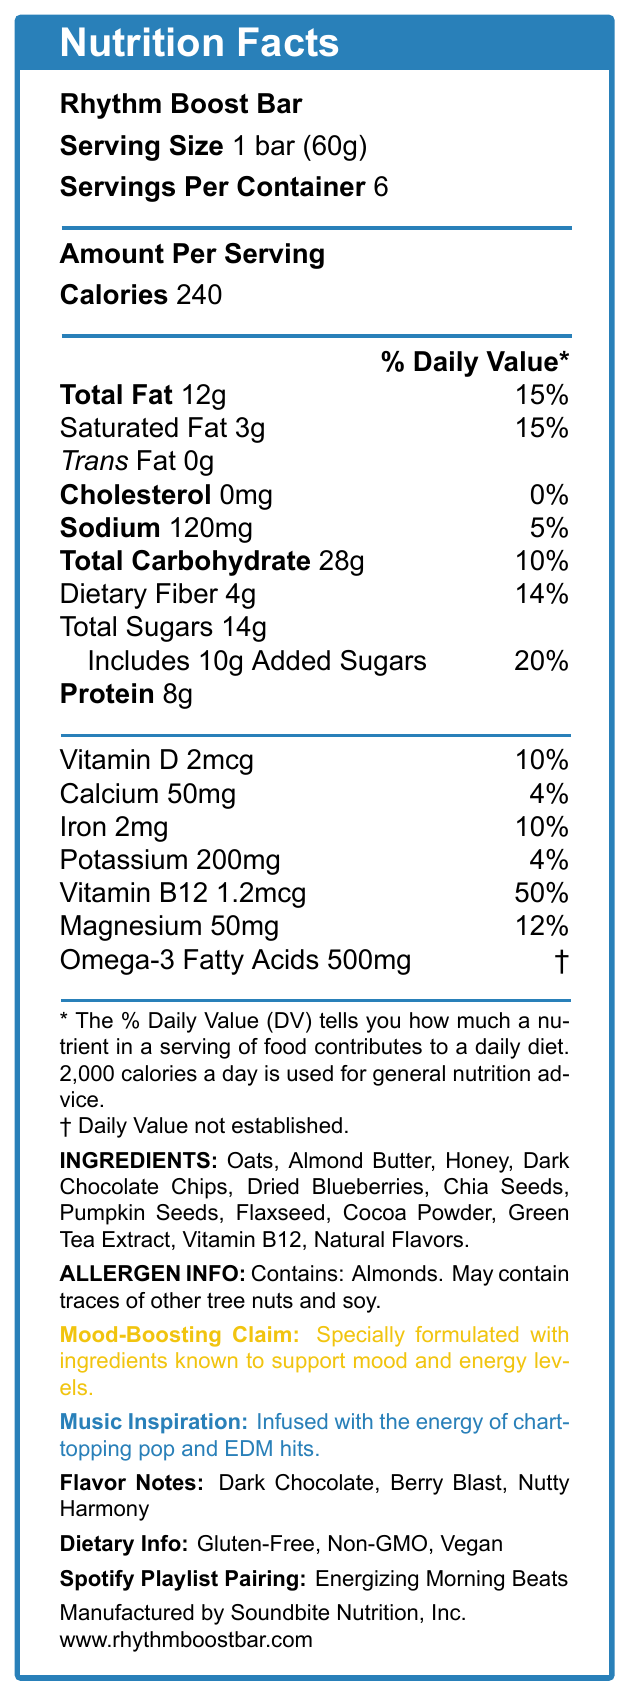what is the serving size of the Rhythm Boost Bar? The serving size is explicitly mentioned as "1 bar (60g)" in the document.
Answer: 1 bar (60g) how many servings are there per container? The document states "Servings Per Container: 6".
Answer: 6 how many calories are there per serving? "Calories" are listed as "240" under "Amount Per Serving".
Answer: 240 what percentage of the daily value for saturated fat does one serving have? Under "Saturated Fat," it notes "3g" and alongside it "15%," representing the daily value percentage.
Answer: 15% list three main flavor notes of the Rhythm Boost Bar. The "Flavor Notes" section lists "Dark Chocolate, Berry Blast, Nutty Harmony."
Answer: Dark Chocolate, Berry Blast, Nutty Harmony how much protein does one bar contain? The "Protein" content is listed as "8g" under the nutrition facts.
Answer: 8g what are the primary allergens in the Rhythm Boost Bar? The "Allergen Info" section states that the product contains almonds and may contain traces of other tree nuts and soy.
Answer: Almonds. May contain traces of other tree nuts and soy. what is the daily value percentage of vitamin B12 in the Rhythm Boost Bar? The document lists "Vitamin B12 1.2mcg" and "50%" as the daily value percentage.
Answer: 50% which company manufactures the Rhythm Boost Bar? The manufacturer is listed at the bottom of the document as "Soundbite Nutrition, Inc."
Answer: Soundbite Nutrition, Inc. which dietary tags are associated with the Rhythm Boost Bar? A. Gluten-Free B. Non-GMO C. Vegan D. All of the above The "Dietary Info" section lists all three tags: "Gluten-Free, Non-GMO, Vegan."
Answer: D. All of the above this product contains which minerals? A. Iron and Calcium B. Potassium and Magnesium C. All of the above D. None of the above The "Nutrition Facts" section shows that the product contains iron, calcium, potassium, and magnesium.
Answer: C. All of the above is the Rhythm Boost Bar vegan? The "Dietary Info" section lists "Vegan" as one of the attributes.
Answer: Yes does the Rhythm Boost Bar contain any cholesterol? The section labeled "Cholesterol" lists "0mg 0%" indicating no cholesterol content.
Answer: No write a summary of the nutrition and dietary features of the Rhythm Boost Bar. This summary covers the critical nutritional and dietary features of the Rhythm Boost Bar based on the document provided.
Answer: The Rhythm Boost Bar contains 240 calories per serving with 12g of total fat, 15% daily value of saturated fat, no trans fat, and 0mg cholesterol. It includes 120mg of sodium (5% DV), 28g of carbohydrates (10% DV) with 4g dietary fiber (14% DV) and 14g total sugars (with 10g added sugars, 20% DV). The bar provides 8g of protein and is fortified with vitamins and minerals such as Vitamin D (2mcg, 10% DV), Calcium (50mg, 4% DV), Iron (2mg, 10% DV), Potassium (200mg, 4% DV), Vitamin B12 (1.2mcg, 50% DV), and Magnesium (50mg, 12% DV). It contains 500mg of Omega-3 fatty acids. Other features include being gluten-free, non-GMO, and vegan, with noted allergen information pertaining to almonds. does the document specify how much honey is used as an ingredient? The document lists honey as an ingredient but does not specify the quantity used.
Answer: Not enough information 